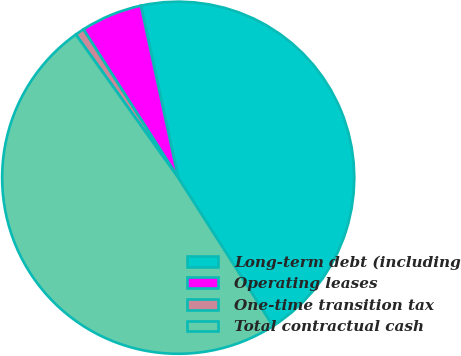Convert chart to OTSL. <chart><loc_0><loc_0><loc_500><loc_500><pie_chart><fcel>Long-term debt (including<fcel>Operating leases<fcel>One-time transition tax<fcel>Total contractual cash<nl><fcel>44.35%<fcel>5.65%<fcel>0.83%<fcel>49.17%<nl></chart> 